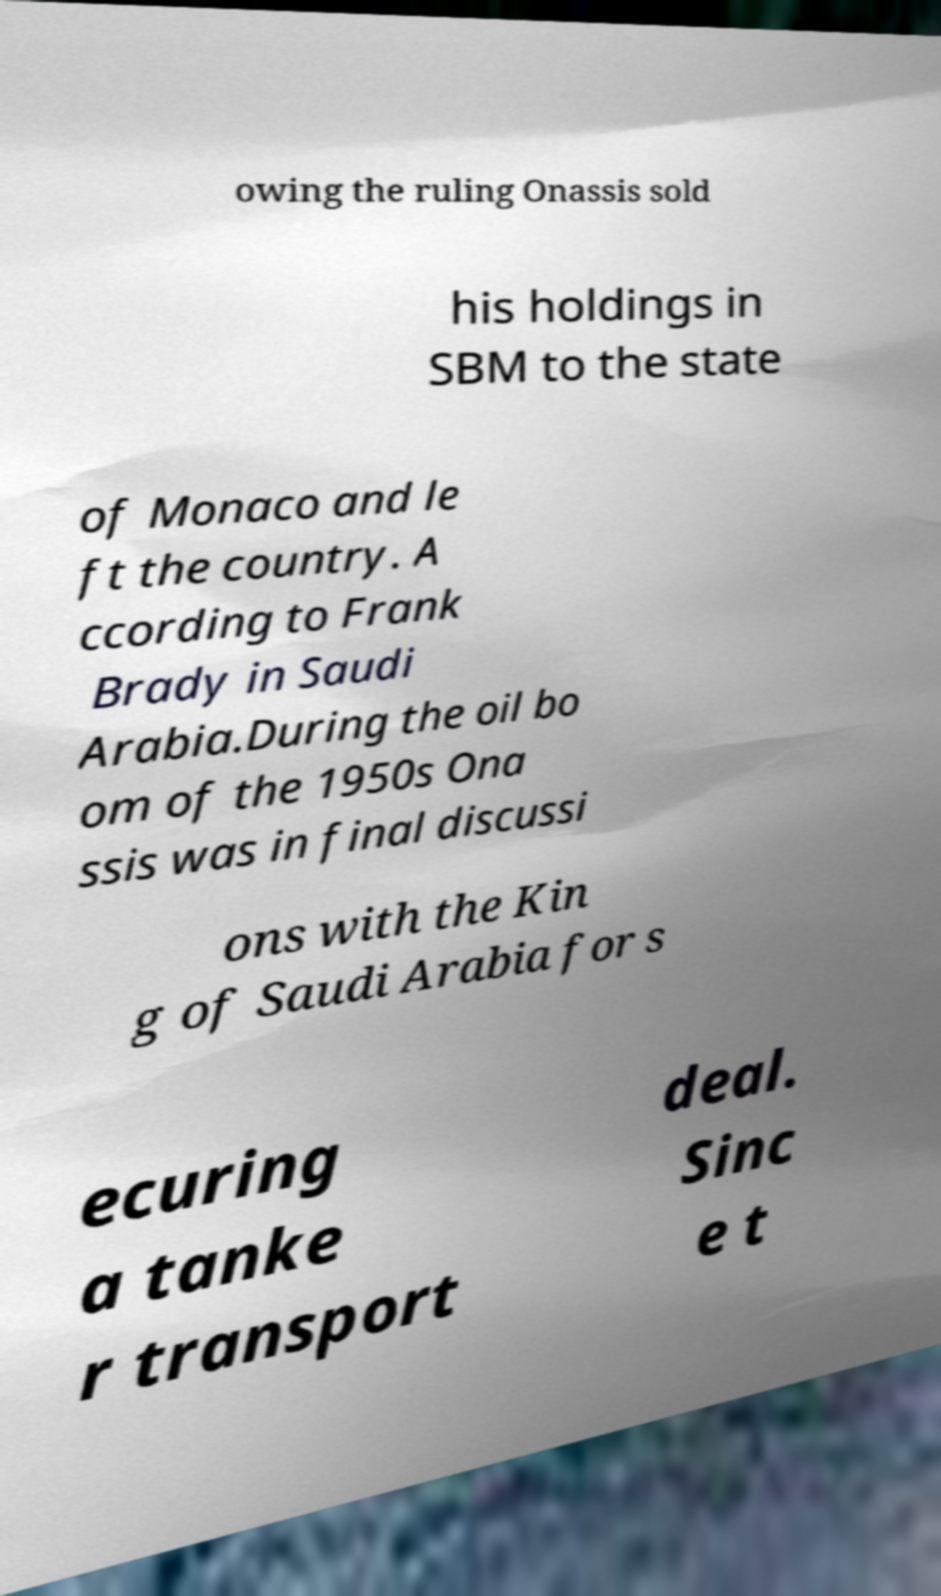There's text embedded in this image that I need extracted. Can you transcribe it verbatim? owing the ruling Onassis sold his holdings in SBM to the state of Monaco and le ft the country. A ccording to Frank Brady in Saudi Arabia.During the oil bo om of the 1950s Ona ssis was in final discussi ons with the Kin g of Saudi Arabia for s ecuring a tanke r transport deal. Sinc e t 